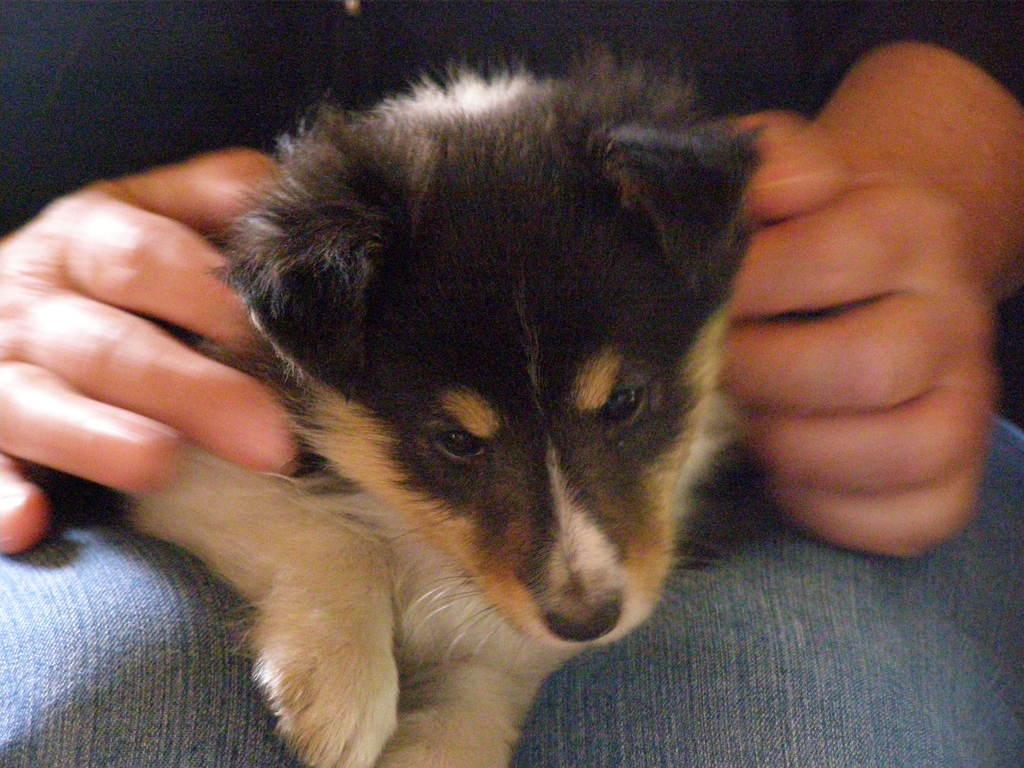Can you describe this image briefly? In this image there is a person holding a dog. 